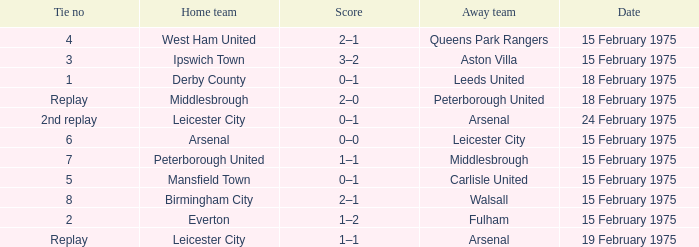What was the date when the away team was the leeds united? 18 February 1975. Can you parse all the data within this table? {'header': ['Tie no', 'Home team', 'Score', 'Away team', 'Date'], 'rows': [['4', 'West Ham United', '2–1', 'Queens Park Rangers', '15 February 1975'], ['3', 'Ipswich Town', '3–2', 'Aston Villa', '15 February 1975'], ['1', 'Derby County', '0–1', 'Leeds United', '18 February 1975'], ['Replay', 'Middlesbrough', '2–0', 'Peterborough United', '18 February 1975'], ['2nd replay', 'Leicester City', '0–1', 'Arsenal', '24 February 1975'], ['6', 'Arsenal', '0–0', 'Leicester City', '15 February 1975'], ['7', 'Peterborough United', '1–1', 'Middlesbrough', '15 February 1975'], ['5', 'Mansfield Town', '0–1', 'Carlisle United', '15 February 1975'], ['8', 'Birmingham City', '2–1', 'Walsall', '15 February 1975'], ['2', 'Everton', '1–2', 'Fulham', '15 February 1975'], ['Replay', 'Leicester City', '1–1', 'Arsenal', '19 February 1975']]} 